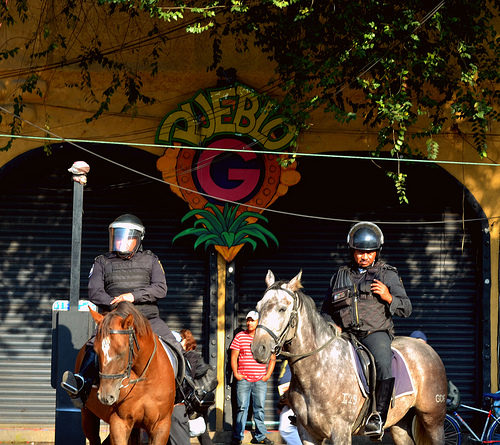How many horses are there? 2 